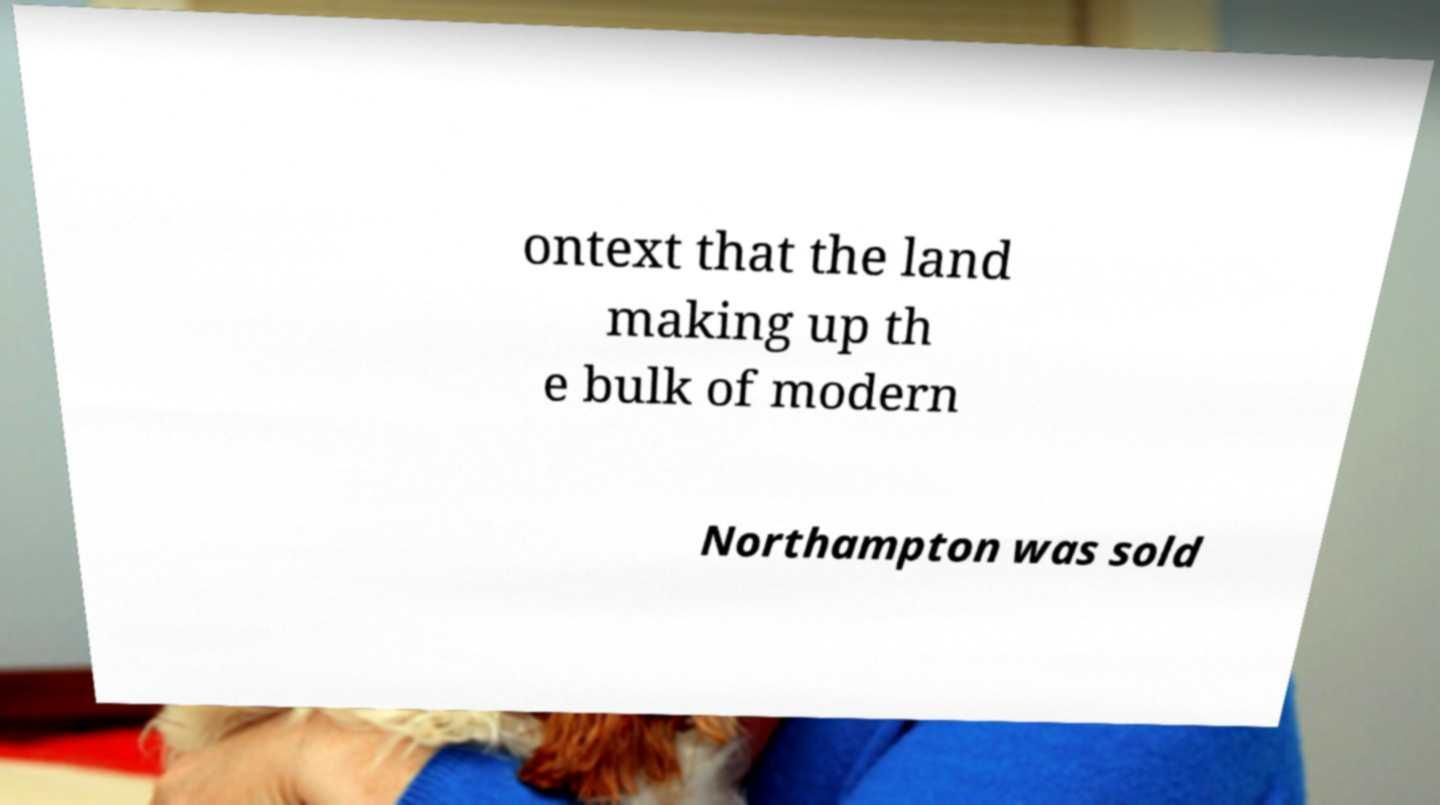Could you assist in decoding the text presented in this image and type it out clearly? ontext that the land making up th e bulk of modern Northampton was sold 